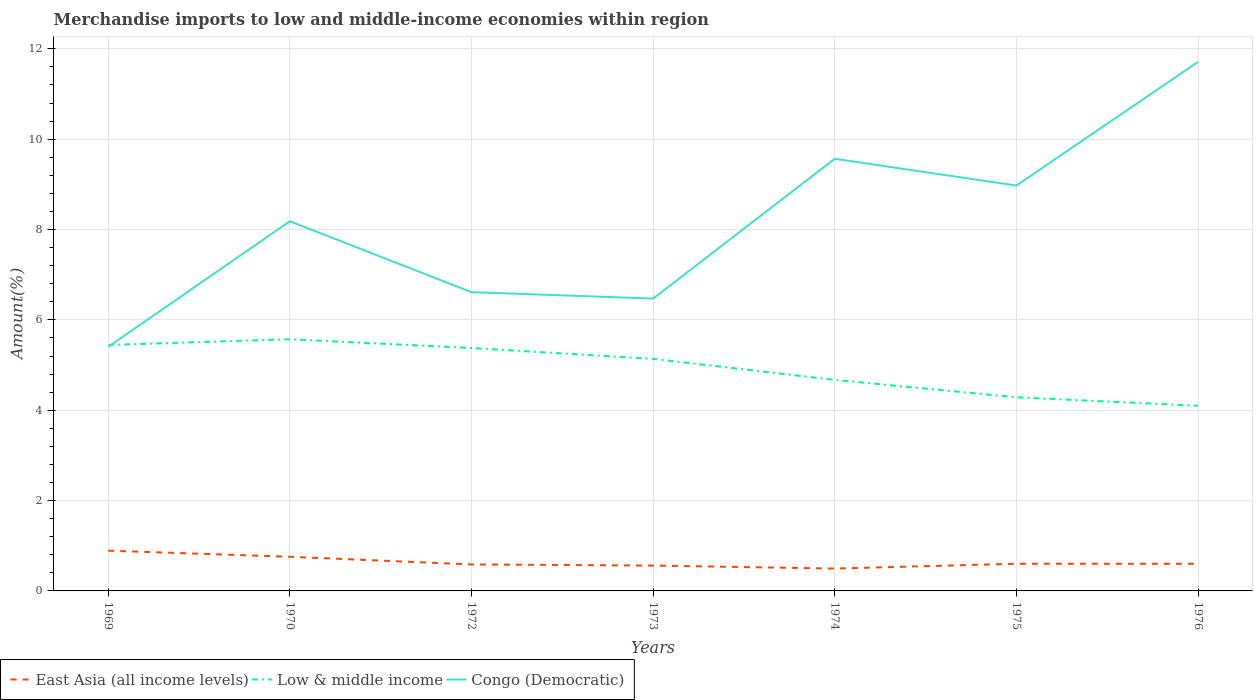How many different coloured lines are there?
Your response must be concise. 3. Does the line corresponding to Low & middle income intersect with the line corresponding to East Asia (all income levels)?
Make the answer very short. No. Is the number of lines equal to the number of legend labels?
Give a very brief answer. Yes. Across all years, what is the maximum percentage of amount earned from merchandise imports in East Asia (all income levels)?
Offer a very short reply. 0.49. In which year was the percentage of amount earned from merchandise imports in East Asia (all income levels) maximum?
Provide a short and direct response. 1974. What is the total percentage of amount earned from merchandise imports in East Asia (all income levels) in the graph?
Offer a very short reply. 0.02. What is the difference between the highest and the second highest percentage of amount earned from merchandise imports in Low & middle income?
Give a very brief answer. 1.47. How many lines are there?
Make the answer very short. 3. What is the difference between two consecutive major ticks on the Y-axis?
Offer a terse response. 2. Are the values on the major ticks of Y-axis written in scientific E-notation?
Ensure brevity in your answer.  No. Does the graph contain any zero values?
Keep it short and to the point. No. Where does the legend appear in the graph?
Provide a short and direct response. Bottom left. What is the title of the graph?
Keep it short and to the point. Merchandise imports to low and middle-income economies within region. What is the label or title of the Y-axis?
Make the answer very short. Amount(%). What is the Amount(%) of East Asia (all income levels) in 1969?
Keep it short and to the point. 0.89. What is the Amount(%) of Low & middle income in 1969?
Provide a short and direct response. 5.44. What is the Amount(%) of Congo (Democratic) in 1969?
Offer a very short reply. 5.4. What is the Amount(%) in East Asia (all income levels) in 1970?
Give a very brief answer. 0.76. What is the Amount(%) of Low & middle income in 1970?
Offer a terse response. 5.57. What is the Amount(%) of Congo (Democratic) in 1970?
Provide a succinct answer. 8.18. What is the Amount(%) of East Asia (all income levels) in 1972?
Give a very brief answer. 0.59. What is the Amount(%) in Low & middle income in 1972?
Provide a short and direct response. 5.38. What is the Amount(%) of Congo (Democratic) in 1972?
Your answer should be compact. 6.61. What is the Amount(%) in East Asia (all income levels) in 1973?
Your answer should be compact. 0.56. What is the Amount(%) of Low & middle income in 1973?
Offer a very short reply. 5.14. What is the Amount(%) in Congo (Democratic) in 1973?
Ensure brevity in your answer.  6.47. What is the Amount(%) of East Asia (all income levels) in 1974?
Keep it short and to the point. 0.49. What is the Amount(%) of Low & middle income in 1974?
Offer a terse response. 4.67. What is the Amount(%) in Congo (Democratic) in 1974?
Give a very brief answer. 9.57. What is the Amount(%) of East Asia (all income levels) in 1975?
Your answer should be compact. 0.6. What is the Amount(%) in Low & middle income in 1975?
Give a very brief answer. 4.29. What is the Amount(%) of Congo (Democratic) in 1975?
Your response must be concise. 8.97. What is the Amount(%) in East Asia (all income levels) in 1976?
Ensure brevity in your answer.  0.6. What is the Amount(%) of Low & middle income in 1976?
Offer a terse response. 4.1. What is the Amount(%) of Congo (Democratic) in 1976?
Keep it short and to the point. 11.71. Across all years, what is the maximum Amount(%) of East Asia (all income levels)?
Provide a short and direct response. 0.89. Across all years, what is the maximum Amount(%) of Low & middle income?
Provide a short and direct response. 5.57. Across all years, what is the maximum Amount(%) of Congo (Democratic)?
Offer a very short reply. 11.71. Across all years, what is the minimum Amount(%) in East Asia (all income levels)?
Your answer should be compact. 0.49. Across all years, what is the minimum Amount(%) in Low & middle income?
Offer a very short reply. 4.1. Across all years, what is the minimum Amount(%) of Congo (Democratic)?
Provide a succinct answer. 5.4. What is the total Amount(%) of East Asia (all income levels) in the graph?
Ensure brevity in your answer.  4.49. What is the total Amount(%) in Low & middle income in the graph?
Offer a very short reply. 34.59. What is the total Amount(%) of Congo (Democratic) in the graph?
Give a very brief answer. 56.92. What is the difference between the Amount(%) of East Asia (all income levels) in 1969 and that in 1970?
Your response must be concise. 0.13. What is the difference between the Amount(%) in Low & middle income in 1969 and that in 1970?
Give a very brief answer. -0.13. What is the difference between the Amount(%) of Congo (Democratic) in 1969 and that in 1970?
Keep it short and to the point. -2.78. What is the difference between the Amount(%) of East Asia (all income levels) in 1969 and that in 1972?
Offer a terse response. 0.3. What is the difference between the Amount(%) of Low & middle income in 1969 and that in 1972?
Provide a short and direct response. 0.07. What is the difference between the Amount(%) in Congo (Democratic) in 1969 and that in 1972?
Give a very brief answer. -1.21. What is the difference between the Amount(%) in East Asia (all income levels) in 1969 and that in 1973?
Give a very brief answer. 0.33. What is the difference between the Amount(%) in Low & middle income in 1969 and that in 1973?
Provide a short and direct response. 0.31. What is the difference between the Amount(%) of Congo (Democratic) in 1969 and that in 1973?
Keep it short and to the point. -1.07. What is the difference between the Amount(%) of East Asia (all income levels) in 1969 and that in 1974?
Make the answer very short. 0.4. What is the difference between the Amount(%) in Low & middle income in 1969 and that in 1974?
Give a very brief answer. 0.77. What is the difference between the Amount(%) of Congo (Democratic) in 1969 and that in 1974?
Provide a short and direct response. -4.16. What is the difference between the Amount(%) of East Asia (all income levels) in 1969 and that in 1975?
Offer a terse response. 0.29. What is the difference between the Amount(%) in Low & middle income in 1969 and that in 1975?
Provide a short and direct response. 1.16. What is the difference between the Amount(%) of Congo (Democratic) in 1969 and that in 1975?
Provide a succinct answer. -3.57. What is the difference between the Amount(%) in East Asia (all income levels) in 1969 and that in 1976?
Provide a succinct answer. 0.29. What is the difference between the Amount(%) in Low & middle income in 1969 and that in 1976?
Your response must be concise. 1.35. What is the difference between the Amount(%) in Congo (Democratic) in 1969 and that in 1976?
Provide a succinct answer. -6.31. What is the difference between the Amount(%) in East Asia (all income levels) in 1970 and that in 1972?
Make the answer very short. 0.17. What is the difference between the Amount(%) in Low & middle income in 1970 and that in 1972?
Offer a terse response. 0.19. What is the difference between the Amount(%) of Congo (Democratic) in 1970 and that in 1972?
Give a very brief answer. 1.57. What is the difference between the Amount(%) in East Asia (all income levels) in 1970 and that in 1973?
Make the answer very short. 0.19. What is the difference between the Amount(%) in Low & middle income in 1970 and that in 1973?
Provide a short and direct response. 0.43. What is the difference between the Amount(%) of Congo (Democratic) in 1970 and that in 1973?
Provide a short and direct response. 1.71. What is the difference between the Amount(%) in East Asia (all income levels) in 1970 and that in 1974?
Provide a short and direct response. 0.26. What is the difference between the Amount(%) of Low & middle income in 1970 and that in 1974?
Make the answer very short. 0.9. What is the difference between the Amount(%) of Congo (Democratic) in 1970 and that in 1974?
Your response must be concise. -1.38. What is the difference between the Amount(%) in East Asia (all income levels) in 1970 and that in 1975?
Your answer should be very brief. 0.15. What is the difference between the Amount(%) of Low & middle income in 1970 and that in 1975?
Offer a very short reply. 1.28. What is the difference between the Amount(%) of Congo (Democratic) in 1970 and that in 1975?
Ensure brevity in your answer.  -0.79. What is the difference between the Amount(%) of East Asia (all income levels) in 1970 and that in 1976?
Offer a very short reply. 0.16. What is the difference between the Amount(%) of Low & middle income in 1970 and that in 1976?
Offer a terse response. 1.47. What is the difference between the Amount(%) of Congo (Democratic) in 1970 and that in 1976?
Your answer should be compact. -3.53. What is the difference between the Amount(%) of East Asia (all income levels) in 1972 and that in 1973?
Provide a succinct answer. 0.02. What is the difference between the Amount(%) in Low & middle income in 1972 and that in 1973?
Give a very brief answer. 0.24. What is the difference between the Amount(%) in Congo (Democratic) in 1972 and that in 1973?
Your answer should be very brief. 0.14. What is the difference between the Amount(%) of East Asia (all income levels) in 1972 and that in 1974?
Provide a succinct answer. 0.09. What is the difference between the Amount(%) in Low & middle income in 1972 and that in 1974?
Offer a very short reply. 0.71. What is the difference between the Amount(%) of Congo (Democratic) in 1972 and that in 1974?
Keep it short and to the point. -2.95. What is the difference between the Amount(%) in East Asia (all income levels) in 1972 and that in 1975?
Ensure brevity in your answer.  -0.02. What is the difference between the Amount(%) in Low & middle income in 1972 and that in 1975?
Provide a short and direct response. 1.09. What is the difference between the Amount(%) in Congo (Democratic) in 1972 and that in 1975?
Give a very brief answer. -2.36. What is the difference between the Amount(%) in East Asia (all income levels) in 1972 and that in 1976?
Your answer should be very brief. -0.01. What is the difference between the Amount(%) of Low & middle income in 1972 and that in 1976?
Make the answer very short. 1.28. What is the difference between the Amount(%) of Congo (Democratic) in 1972 and that in 1976?
Provide a succinct answer. -5.1. What is the difference between the Amount(%) of East Asia (all income levels) in 1973 and that in 1974?
Keep it short and to the point. 0.07. What is the difference between the Amount(%) in Low & middle income in 1973 and that in 1974?
Provide a short and direct response. 0.47. What is the difference between the Amount(%) of Congo (Democratic) in 1973 and that in 1974?
Keep it short and to the point. -3.09. What is the difference between the Amount(%) of East Asia (all income levels) in 1973 and that in 1975?
Your response must be concise. -0.04. What is the difference between the Amount(%) of Low & middle income in 1973 and that in 1975?
Offer a very short reply. 0.85. What is the difference between the Amount(%) of Congo (Democratic) in 1973 and that in 1975?
Give a very brief answer. -2.5. What is the difference between the Amount(%) of East Asia (all income levels) in 1973 and that in 1976?
Make the answer very short. -0.04. What is the difference between the Amount(%) of Low & middle income in 1973 and that in 1976?
Your response must be concise. 1.04. What is the difference between the Amount(%) in Congo (Democratic) in 1973 and that in 1976?
Your answer should be compact. -5.24. What is the difference between the Amount(%) in East Asia (all income levels) in 1974 and that in 1975?
Your response must be concise. -0.11. What is the difference between the Amount(%) in Low & middle income in 1974 and that in 1975?
Keep it short and to the point. 0.39. What is the difference between the Amount(%) in Congo (Democratic) in 1974 and that in 1975?
Offer a very short reply. 0.59. What is the difference between the Amount(%) of East Asia (all income levels) in 1974 and that in 1976?
Provide a short and direct response. -0.11. What is the difference between the Amount(%) in Low & middle income in 1974 and that in 1976?
Provide a short and direct response. 0.57. What is the difference between the Amount(%) of Congo (Democratic) in 1974 and that in 1976?
Make the answer very short. -2.14. What is the difference between the Amount(%) in East Asia (all income levels) in 1975 and that in 1976?
Give a very brief answer. 0. What is the difference between the Amount(%) of Low & middle income in 1975 and that in 1976?
Give a very brief answer. 0.19. What is the difference between the Amount(%) in Congo (Democratic) in 1975 and that in 1976?
Keep it short and to the point. -2.74. What is the difference between the Amount(%) in East Asia (all income levels) in 1969 and the Amount(%) in Low & middle income in 1970?
Ensure brevity in your answer.  -4.68. What is the difference between the Amount(%) of East Asia (all income levels) in 1969 and the Amount(%) of Congo (Democratic) in 1970?
Make the answer very short. -7.29. What is the difference between the Amount(%) in Low & middle income in 1969 and the Amount(%) in Congo (Democratic) in 1970?
Keep it short and to the point. -2.74. What is the difference between the Amount(%) in East Asia (all income levels) in 1969 and the Amount(%) in Low & middle income in 1972?
Keep it short and to the point. -4.49. What is the difference between the Amount(%) in East Asia (all income levels) in 1969 and the Amount(%) in Congo (Democratic) in 1972?
Your answer should be compact. -5.72. What is the difference between the Amount(%) of Low & middle income in 1969 and the Amount(%) of Congo (Democratic) in 1972?
Keep it short and to the point. -1.17. What is the difference between the Amount(%) in East Asia (all income levels) in 1969 and the Amount(%) in Low & middle income in 1973?
Offer a very short reply. -4.25. What is the difference between the Amount(%) in East Asia (all income levels) in 1969 and the Amount(%) in Congo (Democratic) in 1973?
Your answer should be very brief. -5.58. What is the difference between the Amount(%) of Low & middle income in 1969 and the Amount(%) of Congo (Democratic) in 1973?
Make the answer very short. -1.03. What is the difference between the Amount(%) of East Asia (all income levels) in 1969 and the Amount(%) of Low & middle income in 1974?
Your response must be concise. -3.78. What is the difference between the Amount(%) of East Asia (all income levels) in 1969 and the Amount(%) of Congo (Democratic) in 1974?
Your answer should be compact. -8.68. What is the difference between the Amount(%) in Low & middle income in 1969 and the Amount(%) in Congo (Democratic) in 1974?
Keep it short and to the point. -4.12. What is the difference between the Amount(%) in East Asia (all income levels) in 1969 and the Amount(%) in Low & middle income in 1975?
Your response must be concise. -3.4. What is the difference between the Amount(%) in East Asia (all income levels) in 1969 and the Amount(%) in Congo (Democratic) in 1975?
Ensure brevity in your answer.  -8.08. What is the difference between the Amount(%) of Low & middle income in 1969 and the Amount(%) of Congo (Democratic) in 1975?
Your answer should be compact. -3.53. What is the difference between the Amount(%) in East Asia (all income levels) in 1969 and the Amount(%) in Low & middle income in 1976?
Provide a short and direct response. -3.21. What is the difference between the Amount(%) of East Asia (all income levels) in 1969 and the Amount(%) of Congo (Democratic) in 1976?
Your answer should be very brief. -10.82. What is the difference between the Amount(%) of Low & middle income in 1969 and the Amount(%) of Congo (Democratic) in 1976?
Provide a succinct answer. -6.27. What is the difference between the Amount(%) in East Asia (all income levels) in 1970 and the Amount(%) in Low & middle income in 1972?
Ensure brevity in your answer.  -4.62. What is the difference between the Amount(%) in East Asia (all income levels) in 1970 and the Amount(%) in Congo (Democratic) in 1972?
Offer a terse response. -5.86. What is the difference between the Amount(%) of Low & middle income in 1970 and the Amount(%) of Congo (Democratic) in 1972?
Ensure brevity in your answer.  -1.04. What is the difference between the Amount(%) of East Asia (all income levels) in 1970 and the Amount(%) of Low & middle income in 1973?
Keep it short and to the point. -4.38. What is the difference between the Amount(%) of East Asia (all income levels) in 1970 and the Amount(%) of Congo (Democratic) in 1973?
Your answer should be very brief. -5.72. What is the difference between the Amount(%) of Low & middle income in 1970 and the Amount(%) of Congo (Democratic) in 1973?
Provide a short and direct response. -0.9. What is the difference between the Amount(%) of East Asia (all income levels) in 1970 and the Amount(%) of Low & middle income in 1974?
Your answer should be very brief. -3.92. What is the difference between the Amount(%) in East Asia (all income levels) in 1970 and the Amount(%) in Congo (Democratic) in 1974?
Keep it short and to the point. -8.81. What is the difference between the Amount(%) of Low & middle income in 1970 and the Amount(%) of Congo (Democratic) in 1974?
Your answer should be compact. -4. What is the difference between the Amount(%) of East Asia (all income levels) in 1970 and the Amount(%) of Low & middle income in 1975?
Your answer should be compact. -3.53. What is the difference between the Amount(%) of East Asia (all income levels) in 1970 and the Amount(%) of Congo (Democratic) in 1975?
Provide a succinct answer. -8.22. What is the difference between the Amount(%) in Low & middle income in 1970 and the Amount(%) in Congo (Democratic) in 1975?
Your answer should be compact. -3.4. What is the difference between the Amount(%) of East Asia (all income levels) in 1970 and the Amount(%) of Low & middle income in 1976?
Keep it short and to the point. -3.34. What is the difference between the Amount(%) of East Asia (all income levels) in 1970 and the Amount(%) of Congo (Democratic) in 1976?
Ensure brevity in your answer.  -10.95. What is the difference between the Amount(%) of Low & middle income in 1970 and the Amount(%) of Congo (Democratic) in 1976?
Provide a short and direct response. -6.14. What is the difference between the Amount(%) in East Asia (all income levels) in 1972 and the Amount(%) in Low & middle income in 1973?
Give a very brief answer. -4.55. What is the difference between the Amount(%) of East Asia (all income levels) in 1972 and the Amount(%) of Congo (Democratic) in 1973?
Your answer should be compact. -5.89. What is the difference between the Amount(%) of Low & middle income in 1972 and the Amount(%) of Congo (Democratic) in 1973?
Ensure brevity in your answer.  -1.09. What is the difference between the Amount(%) of East Asia (all income levels) in 1972 and the Amount(%) of Low & middle income in 1974?
Provide a short and direct response. -4.09. What is the difference between the Amount(%) in East Asia (all income levels) in 1972 and the Amount(%) in Congo (Democratic) in 1974?
Your answer should be very brief. -8.98. What is the difference between the Amount(%) in Low & middle income in 1972 and the Amount(%) in Congo (Democratic) in 1974?
Offer a very short reply. -4.19. What is the difference between the Amount(%) in East Asia (all income levels) in 1972 and the Amount(%) in Low & middle income in 1975?
Make the answer very short. -3.7. What is the difference between the Amount(%) in East Asia (all income levels) in 1972 and the Amount(%) in Congo (Democratic) in 1975?
Your answer should be very brief. -8.39. What is the difference between the Amount(%) in Low & middle income in 1972 and the Amount(%) in Congo (Democratic) in 1975?
Offer a terse response. -3.6. What is the difference between the Amount(%) in East Asia (all income levels) in 1972 and the Amount(%) in Low & middle income in 1976?
Your answer should be compact. -3.51. What is the difference between the Amount(%) of East Asia (all income levels) in 1972 and the Amount(%) of Congo (Democratic) in 1976?
Give a very brief answer. -11.12. What is the difference between the Amount(%) of Low & middle income in 1972 and the Amount(%) of Congo (Democratic) in 1976?
Provide a succinct answer. -6.33. What is the difference between the Amount(%) in East Asia (all income levels) in 1973 and the Amount(%) in Low & middle income in 1974?
Provide a short and direct response. -4.11. What is the difference between the Amount(%) in East Asia (all income levels) in 1973 and the Amount(%) in Congo (Democratic) in 1974?
Your answer should be compact. -9. What is the difference between the Amount(%) in Low & middle income in 1973 and the Amount(%) in Congo (Democratic) in 1974?
Your answer should be very brief. -4.43. What is the difference between the Amount(%) in East Asia (all income levels) in 1973 and the Amount(%) in Low & middle income in 1975?
Your response must be concise. -3.72. What is the difference between the Amount(%) in East Asia (all income levels) in 1973 and the Amount(%) in Congo (Democratic) in 1975?
Keep it short and to the point. -8.41. What is the difference between the Amount(%) of Low & middle income in 1973 and the Amount(%) of Congo (Democratic) in 1975?
Ensure brevity in your answer.  -3.84. What is the difference between the Amount(%) of East Asia (all income levels) in 1973 and the Amount(%) of Low & middle income in 1976?
Your answer should be compact. -3.54. What is the difference between the Amount(%) in East Asia (all income levels) in 1973 and the Amount(%) in Congo (Democratic) in 1976?
Offer a terse response. -11.15. What is the difference between the Amount(%) in Low & middle income in 1973 and the Amount(%) in Congo (Democratic) in 1976?
Your answer should be compact. -6.57. What is the difference between the Amount(%) of East Asia (all income levels) in 1974 and the Amount(%) of Low & middle income in 1975?
Offer a very short reply. -3.79. What is the difference between the Amount(%) in East Asia (all income levels) in 1974 and the Amount(%) in Congo (Democratic) in 1975?
Provide a succinct answer. -8.48. What is the difference between the Amount(%) of Low & middle income in 1974 and the Amount(%) of Congo (Democratic) in 1975?
Keep it short and to the point. -4.3. What is the difference between the Amount(%) of East Asia (all income levels) in 1974 and the Amount(%) of Low & middle income in 1976?
Ensure brevity in your answer.  -3.6. What is the difference between the Amount(%) in East Asia (all income levels) in 1974 and the Amount(%) in Congo (Democratic) in 1976?
Your answer should be compact. -11.22. What is the difference between the Amount(%) in Low & middle income in 1974 and the Amount(%) in Congo (Democratic) in 1976?
Provide a succinct answer. -7.04. What is the difference between the Amount(%) in East Asia (all income levels) in 1975 and the Amount(%) in Low & middle income in 1976?
Provide a succinct answer. -3.5. What is the difference between the Amount(%) of East Asia (all income levels) in 1975 and the Amount(%) of Congo (Democratic) in 1976?
Offer a terse response. -11.11. What is the difference between the Amount(%) in Low & middle income in 1975 and the Amount(%) in Congo (Democratic) in 1976?
Make the answer very short. -7.42. What is the average Amount(%) of East Asia (all income levels) per year?
Your answer should be very brief. 0.64. What is the average Amount(%) of Low & middle income per year?
Keep it short and to the point. 4.94. What is the average Amount(%) of Congo (Democratic) per year?
Ensure brevity in your answer.  8.13. In the year 1969, what is the difference between the Amount(%) of East Asia (all income levels) and Amount(%) of Low & middle income?
Your response must be concise. -4.55. In the year 1969, what is the difference between the Amount(%) of East Asia (all income levels) and Amount(%) of Congo (Democratic)?
Your answer should be very brief. -4.51. In the year 1969, what is the difference between the Amount(%) in Low & middle income and Amount(%) in Congo (Democratic)?
Make the answer very short. 0.04. In the year 1970, what is the difference between the Amount(%) of East Asia (all income levels) and Amount(%) of Low & middle income?
Offer a terse response. -4.81. In the year 1970, what is the difference between the Amount(%) of East Asia (all income levels) and Amount(%) of Congo (Democratic)?
Provide a short and direct response. -7.43. In the year 1970, what is the difference between the Amount(%) of Low & middle income and Amount(%) of Congo (Democratic)?
Ensure brevity in your answer.  -2.61. In the year 1972, what is the difference between the Amount(%) in East Asia (all income levels) and Amount(%) in Low & middle income?
Ensure brevity in your answer.  -4.79. In the year 1972, what is the difference between the Amount(%) of East Asia (all income levels) and Amount(%) of Congo (Democratic)?
Keep it short and to the point. -6.03. In the year 1972, what is the difference between the Amount(%) of Low & middle income and Amount(%) of Congo (Democratic)?
Your answer should be compact. -1.24. In the year 1973, what is the difference between the Amount(%) of East Asia (all income levels) and Amount(%) of Low & middle income?
Ensure brevity in your answer.  -4.58. In the year 1973, what is the difference between the Amount(%) of East Asia (all income levels) and Amount(%) of Congo (Democratic)?
Provide a succinct answer. -5.91. In the year 1973, what is the difference between the Amount(%) in Low & middle income and Amount(%) in Congo (Democratic)?
Your answer should be compact. -1.33. In the year 1974, what is the difference between the Amount(%) in East Asia (all income levels) and Amount(%) in Low & middle income?
Ensure brevity in your answer.  -4.18. In the year 1974, what is the difference between the Amount(%) of East Asia (all income levels) and Amount(%) of Congo (Democratic)?
Your response must be concise. -9.07. In the year 1974, what is the difference between the Amount(%) in Low & middle income and Amount(%) in Congo (Democratic)?
Provide a succinct answer. -4.89. In the year 1975, what is the difference between the Amount(%) of East Asia (all income levels) and Amount(%) of Low & middle income?
Provide a succinct answer. -3.68. In the year 1975, what is the difference between the Amount(%) of East Asia (all income levels) and Amount(%) of Congo (Democratic)?
Give a very brief answer. -8.37. In the year 1975, what is the difference between the Amount(%) in Low & middle income and Amount(%) in Congo (Democratic)?
Give a very brief answer. -4.69. In the year 1976, what is the difference between the Amount(%) of East Asia (all income levels) and Amount(%) of Low & middle income?
Keep it short and to the point. -3.5. In the year 1976, what is the difference between the Amount(%) in East Asia (all income levels) and Amount(%) in Congo (Democratic)?
Offer a terse response. -11.11. In the year 1976, what is the difference between the Amount(%) in Low & middle income and Amount(%) in Congo (Democratic)?
Give a very brief answer. -7.61. What is the ratio of the Amount(%) of East Asia (all income levels) in 1969 to that in 1970?
Provide a short and direct response. 1.18. What is the ratio of the Amount(%) of Low & middle income in 1969 to that in 1970?
Make the answer very short. 0.98. What is the ratio of the Amount(%) of Congo (Democratic) in 1969 to that in 1970?
Give a very brief answer. 0.66. What is the ratio of the Amount(%) in East Asia (all income levels) in 1969 to that in 1972?
Provide a short and direct response. 1.52. What is the ratio of the Amount(%) in Low & middle income in 1969 to that in 1972?
Keep it short and to the point. 1.01. What is the ratio of the Amount(%) in Congo (Democratic) in 1969 to that in 1972?
Provide a succinct answer. 0.82. What is the ratio of the Amount(%) of East Asia (all income levels) in 1969 to that in 1973?
Make the answer very short. 1.59. What is the ratio of the Amount(%) in Low & middle income in 1969 to that in 1973?
Your response must be concise. 1.06. What is the ratio of the Amount(%) in Congo (Democratic) in 1969 to that in 1973?
Make the answer very short. 0.83. What is the ratio of the Amount(%) in East Asia (all income levels) in 1969 to that in 1974?
Make the answer very short. 1.8. What is the ratio of the Amount(%) in Low & middle income in 1969 to that in 1974?
Your response must be concise. 1.17. What is the ratio of the Amount(%) in Congo (Democratic) in 1969 to that in 1974?
Keep it short and to the point. 0.56. What is the ratio of the Amount(%) in East Asia (all income levels) in 1969 to that in 1975?
Your answer should be very brief. 1.48. What is the ratio of the Amount(%) of Low & middle income in 1969 to that in 1975?
Make the answer very short. 1.27. What is the ratio of the Amount(%) in Congo (Democratic) in 1969 to that in 1975?
Your answer should be compact. 0.6. What is the ratio of the Amount(%) in East Asia (all income levels) in 1969 to that in 1976?
Provide a short and direct response. 1.48. What is the ratio of the Amount(%) of Low & middle income in 1969 to that in 1976?
Make the answer very short. 1.33. What is the ratio of the Amount(%) in Congo (Democratic) in 1969 to that in 1976?
Give a very brief answer. 0.46. What is the ratio of the Amount(%) in East Asia (all income levels) in 1970 to that in 1972?
Offer a terse response. 1.29. What is the ratio of the Amount(%) in Low & middle income in 1970 to that in 1972?
Make the answer very short. 1.04. What is the ratio of the Amount(%) of Congo (Democratic) in 1970 to that in 1972?
Give a very brief answer. 1.24. What is the ratio of the Amount(%) of East Asia (all income levels) in 1970 to that in 1973?
Your answer should be compact. 1.35. What is the ratio of the Amount(%) of Low & middle income in 1970 to that in 1973?
Keep it short and to the point. 1.08. What is the ratio of the Amount(%) of Congo (Democratic) in 1970 to that in 1973?
Make the answer very short. 1.26. What is the ratio of the Amount(%) of East Asia (all income levels) in 1970 to that in 1974?
Your answer should be very brief. 1.53. What is the ratio of the Amount(%) of Low & middle income in 1970 to that in 1974?
Provide a succinct answer. 1.19. What is the ratio of the Amount(%) in Congo (Democratic) in 1970 to that in 1974?
Keep it short and to the point. 0.86. What is the ratio of the Amount(%) in East Asia (all income levels) in 1970 to that in 1975?
Your answer should be very brief. 1.26. What is the ratio of the Amount(%) of Low & middle income in 1970 to that in 1975?
Your response must be concise. 1.3. What is the ratio of the Amount(%) in Congo (Democratic) in 1970 to that in 1975?
Provide a succinct answer. 0.91. What is the ratio of the Amount(%) of East Asia (all income levels) in 1970 to that in 1976?
Keep it short and to the point. 1.26. What is the ratio of the Amount(%) of Low & middle income in 1970 to that in 1976?
Offer a very short reply. 1.36. What is the ratio of the Amount(%) of Congo (Democratic) in 1970 to that in 1976?
Your answer should be very brief. 0.7. What is the ratio of the Amount(%) in East Asia (all income levels) in 1972 to that in 1973?
Ensure brevity in your answer.  1.04. What is the ratio of the Amount(%) of Low & middle income in 1972 to that in 1973?
Provide a short and direct response. 1.05. What is the ratio of the Amount(%) of Congo (Democratic) in 1972 to that in 1973?
Give a very brief answer. 1.02. What is the ratio of the Amount(%) of East Asia (all income levels) in 1972 to that in 1974?
Your answer should be compact. 1.18. What is the ratio of the Amount(%) in Low & middle income in 1972 to that in 1974?
Provide a short and direct response. 1.15. What is the ratio of the Amount(%) of Congo (Democratic) in 1972 to that in 1974?
Provide a short and direct response. 0.69. What is the ratio of the Amount(%) in East Asia (all income levels) in 1972 to that in 1975?
Your answer should be compact. 0.97. What is the ratio of the Amount(%) of Low & middle income in 1972 to that in 1975?
Provide a succinct answer. 1.25. What is the ratio of the Amount(%) of Congo (Democratic) in 1972 to that in 1975?
Give a very brief answer. 0.74. What is the ratio of the Amount(%) of Low & middle income in 1972 to that in 1976?
Your answer should be very brief. 1.31. What is the ratio of the Amount(%) in Congo (Democratic) in 1972 to that in 1976?
Ensure brevity in your answer.  0.56. What is the ratio of the Amount(%) in East Asia (all income levels) in 1973 to that in 1974?
Your response must be concise. 1.13. What is the ratio of the Amount(%) in Low & middle income in 1973 to that in 1974?
Your response must be concise. 1.1. What is the ratio of the Amount(%) of Congo (Democratic) in 1973 to that in 1974?
Make the answer very short. 0.68. What is the ratio of the Amount(%) of East Asia (all income levels) in 1973 to that in 1975?
Provide a short and direct response. 0.93. What is the ratio of the Amount(%) in Low & middle income in 1973 to that in 1975?
Offer a terse response. 1.2. What is the ratio of the Amount(%) in Congo (Democratic) in 1973 to that in 1975?
Provide a short and direct response. 0.72. What is the ratio of the Amount(%) in East Asia (all income levels) in 1973 to that in 1976?
Your response must be concise. 0.94. What is the ratio of the Amount(%) of Low & middle income in 1973 to that in 1976?
Offer a very short reply. 1.25. What is the ratio of the Amount(%) of Congo (Democratic) in 1973 to that in 1976?
Your response must be concise. 0.55. What is the ratio of the Amount(%) of East Asia (all income levels) in 1974 to that in 1975?
Provide a short and direct response. 0.82. What is the ratio of the Amount(%) in Low & middle income in 1974 to that in 1975?
Keep it short and to the point. 1.09. What is the ratio of the Amount(%) in Congo (Democratic) in 1974 to that in 1975?
Your answer should be very brief. 1.07. What is the ratio of the Amount(%) in East Asia (all income levels) in 1974 to that in 1976?
Offer a terse response. 0.82. What is the ratio of the Amount(%) in Low & middle income in 1974 to that in 1976?
Offer a very short reply. 1.14. What is the ratio of the Amount(%) of Congo (Democratic) in 1974 to that in 1976?
Make the answer very short. 0.82. What is the ratio of the Amount(%) of East Asia (all income levels) in 1975 to that in 1976?
Your answer should be very brief. 1. What is the ratio of the Amount(%) of Low & middle income in 1975 to that in 1976?
Provide a succinct answer. 1.05. What is the ratio of the Amount(%) in Congo (Democratic) in 1975 to that in 1976?
Your answer should be very brief. 0.77. What is the difference between the highest and the second highest Amount(%) of East Asia (all income levels)?
Your answer should be compact. 0.13. What is the difference between the highest and the second highest Amount(%) in Low & middle income?
Ensure brevity in your answer.  0.13. What is the difference between the highest and the second highest Amount(%) of Congo (Democratic)?
Your answer should be very brief. 2.14. What is the difference between the highest and the lowest Amount(%) of East Asia (all income levels)?
Provide a succinct answer. 0.4. What is the difference between the highest and the lowest Amount(%) in Low & middle income?
Ensure brevity in your answer.  1.47. What is the difference between the highest and the lowest Amount(%) in Congo (Democratic)?
Your answer should be compact. 6.31. 